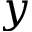Convert formula to latex. <formula><loc_0><loc_0><loc_500><loc_500>y</formula> 